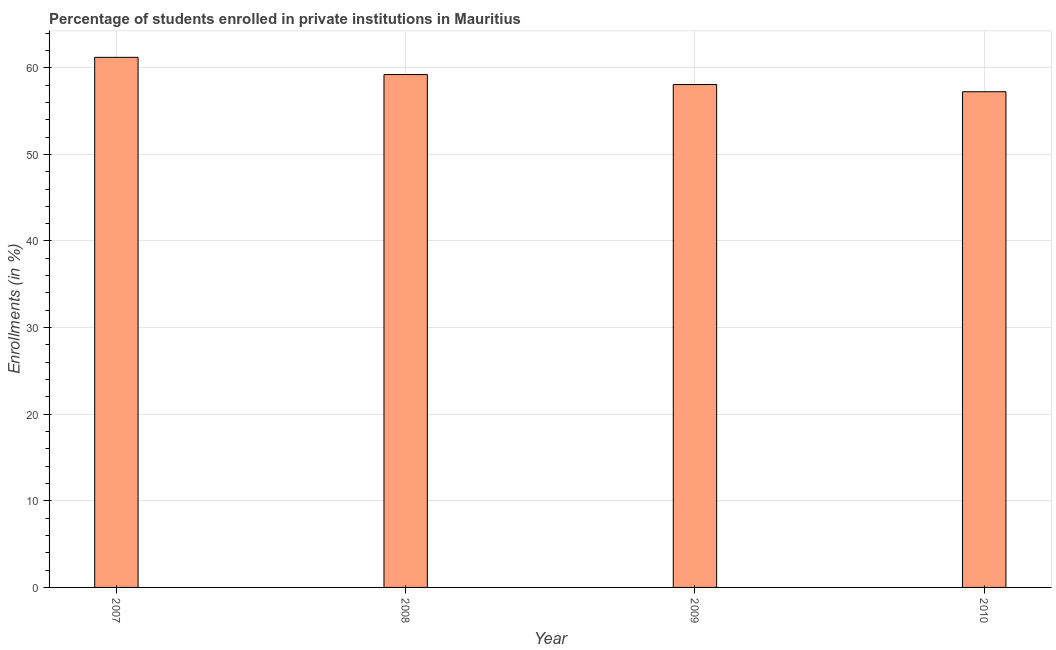Does the graph contain any zero values?
Your answer should be very brief. No. What is the title of the graph?
Offer a terse response. Percentage of students enrolled in private institutions in Mauritius. What is the label or title of the X-axis?
Your response must be concise. Year. What is the label or title of the Y-axis?
Provide a short and direct response. Enrollments (in %). What is the enrollments in private institutions in 2009?
Your answer should be very brief. 58.07. Across all years, what is the maximum enrollments in private institutions?
Your answer should be compact. 61.2. Across all years, what is the minimum enrollments in private institutions?
Make the answer very short. 57.23. In which year was the enrollments in private institutions maximum?
Ensure brevity in your answer.  2007. What is the sum of the enrollments in private institutions?
Ensure brevity in your answer.  235.72. What is the difference between the enrollments in private institutions in 2007 and 2008?
Give a very brief answer. 1.99. What is the average enrollments in private institutions per year?
Give a very brief answer. 58.93. What is the median enrollments in private institutions?
Offer a very short reply. 58.64. In how many years, is the enrollments in private institutions greater than 12 %?
Make the answer very short. 4. Is the enrollments in private institutions in 2008 less than that in 2010?
Keep it short and to the point. No. Is the difference between the enrollments in private institutions in 2008 and 2010 greater than the difference between any two years?
Offer a very short reply. No. What is the difference between the highest and the second highest enrollments in private institutions?
Give a very brief answer. 1.99. Is the sum of the enrollments in private institutions in 2009 and 2010 greater than the maximum enrollments in private institutions across all years?
Provide a succinct answer. Yes. What is the difference between the highest and the lowest enrollments in private institutions?
Offer a very short reply. 3.97. In how many years, is the enrollments in private institutions greater than the average enrollments in private institutions taken over all years?
Give a very brief answer. 2. Are all the bars in the graph horizontal?
Provide a short and direct response. No. What is the difference between two consecutive major ticks on the Y-axis?
Your answer should be very brief. 10. Are the values on the major ticks of Y-axis written in scientific E-notation?
Keep it short and to the point. No. What is the Enrollments (in %) of 2007?
Your answer should be compact. 61.2. What is the Enrollments (in %) of 2008?
Your answer should be very brief. 59.21. What is the Enrollments (in %) of 2009?
Make the answer very short. 58.07. What is the Enrollments (in %) of 2010?
Provide a succinct answer. 57.23. What is the difference between the Enrollments (in %) in 2007 and 2008?
Keep it short and to the point. 1.99. What is the difference between the Enrollments (in %) in 2007 and 2009?
Provide a succinct answer. 3.14. What is the difference between the Enrollments (in %) in 2007 and 2010?
Provide a succinct answer. 3.97. What is the difference between the Enrollments (in %) in 2008 and 2009?
Offer a terse response. 1.15. What is the difference between the Enrollments (in %) in 2008 and 2010?
Provide a short and direct response. 1.98. What is the difference between the Enrollments (in %) in 2009 and 2010?
Ensure brevity in your answer.  0.84. What is the ratio of the Enrollments (in %) in 2007 to that in 2008?
Ensure brevity in your answer.  1.03. What is the ratio of the Enrollments (in %) in 2007 to that in 2009?
Ensure brevity in your answer.  1.05. What is the ratio of the Enrollments (in %) in 2007 to that in 2010?
Provide a short and direct response. 1.07. What is the ratio of the Enrollments (in %) in 2008 to that in 2010?
Provide a succinct answer. 1.03. 